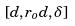Convert formula to latex. <formula><loc_0><loc_0><loc_500><loc_500>[ d , r _ { o } d , \delta ]</formula> 